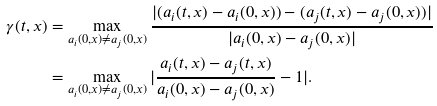Convert formula to latex. <formula><loc_0><loc_0><loc_500><loc_500>\gamma ( t , x ) & = \max _ { a _ { i } ( 0 , x ) \ne a _ { j } ( 0 , x ) } \frac { | ( a _ { i } ( t , x ) - a _ { i } ( 0 , x ) ) - ( a _ { j } ( t , x ) - a _ { j } ( 0 , x ) ) | } { | a _ { i } ( 0 , x ) - a _ { j } ( 0 , x ) | } \\ & = \max _ { a _ { i } ( 0 , x ) \ne a _ { j } ( 0 , x ) } | \frac { a _ { i } ( t , x ) - a _ { j } ( t , x ) } { a _ { i } ( 0 , x ) - a _ { j } ( 0 , x ) } - 1 | .</formula> 